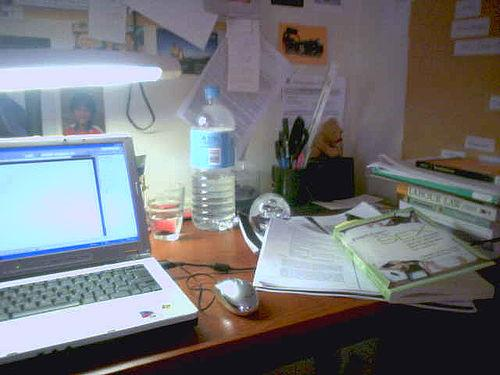What might sit in the glass? water 